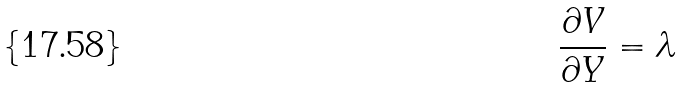<formula> <loc_0><loc_0><loc_500><loc_500>\frac { \partial V } { \partial Y } = \lambda</formula> 